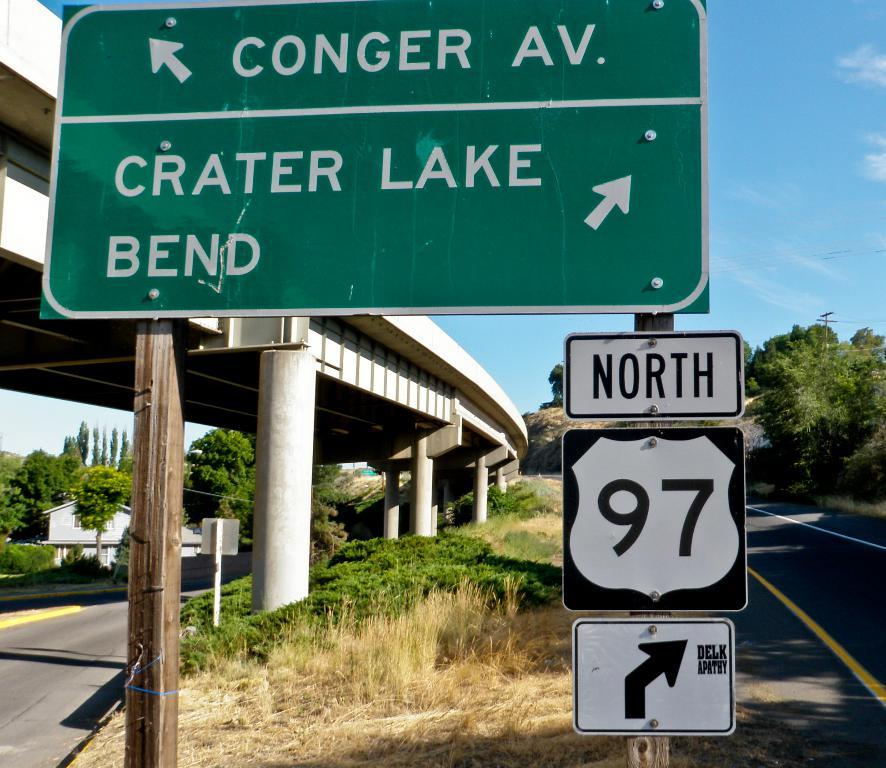<image>
Present a compact description of the photo's key features. a North 97 sign that is below a green sign 